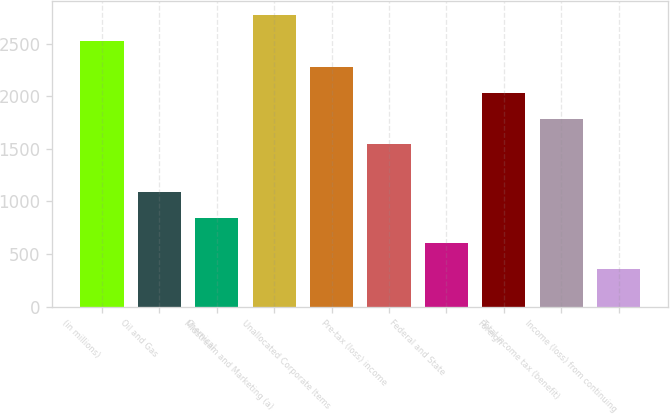Convert chart. <chart><loc_0><loc_0><loc_500><loc_500><bar_chart><fcel>(in millions)<fcel>Oil and Gas<fcel>Chemical<fcel>Midstream and Marketing (a)<fcel>Unallocated Corporate Items<fcel>Pre-tax (loss) income<fcel>Federal and State<fcel>Foreign<fcel>Total income tax (benefit)<fcel>Income (loss) from continuing<nl><fcel>2523<fcel>1091<fcel>845.5<fcel>2768.5<fcel>2277.5<fcel>1541<fcel>600<fcel>2032<fcel>1786.5<fcel>354.5<nl></chart> 